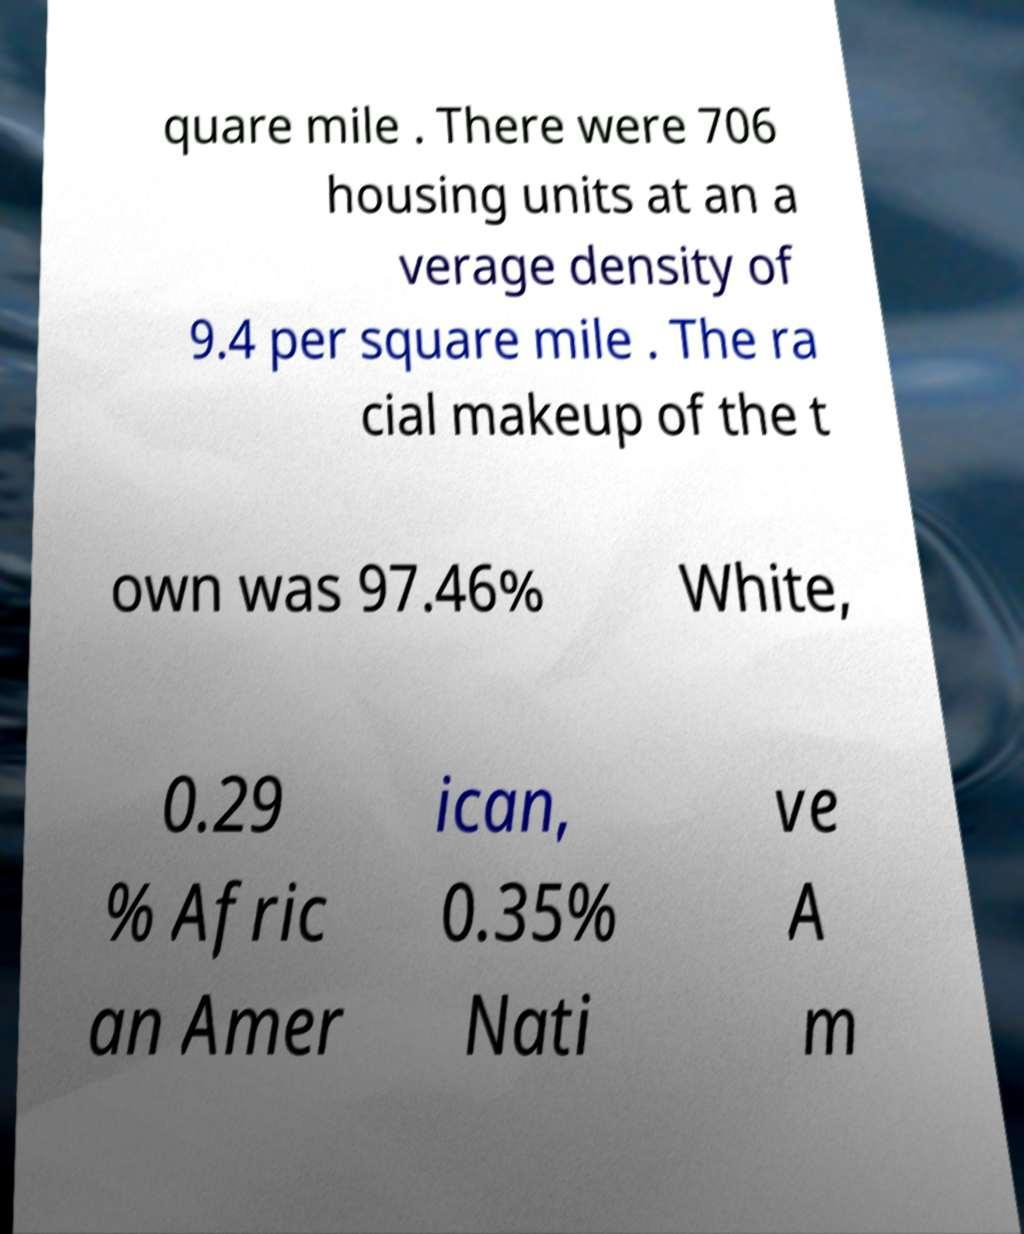Can you read and provide the text displayed in the image?This photo seems to have some interesting text. Can you extract and type it out for me? quare mile . There were 706 housing units at an a verage density of 9.4 per square mile . The ra cial makeup of the t own was 97.46% White, 0.29 % Afric an Amer ican, 0.35% Nati ve A m 